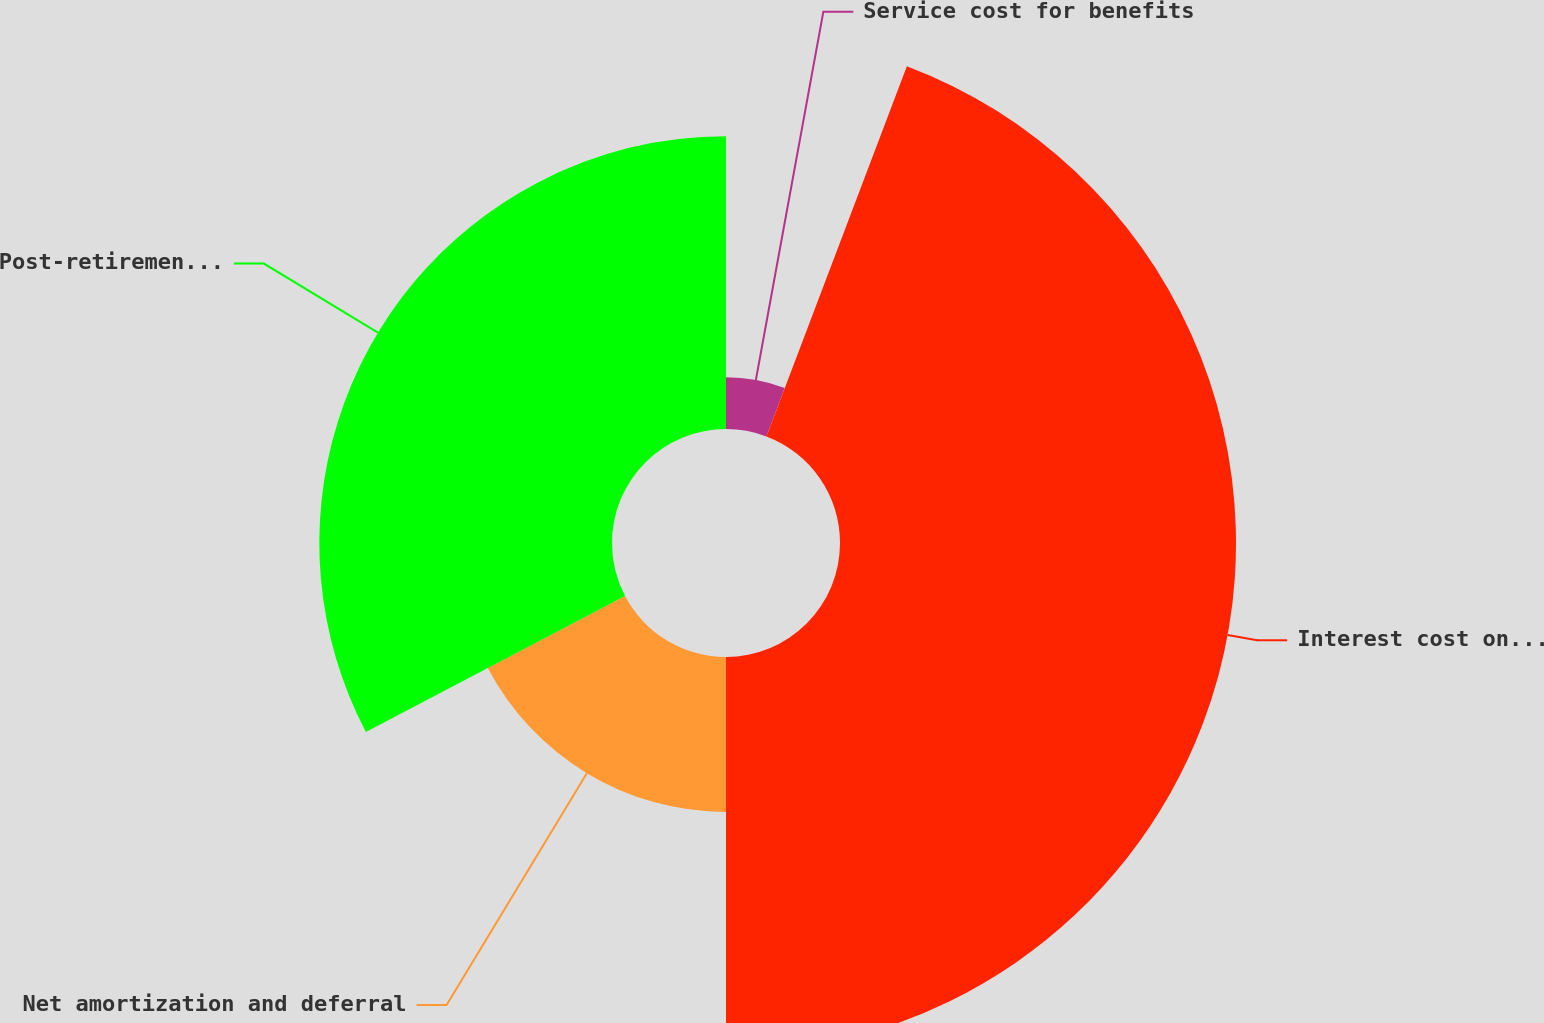Convert chart to OTSL. <chart><loc_0><loc_0><loc_500><loc_500><pie_chart><fcel>Service cost for benefits<fcel>Interest cost on benefit<fcel>Net amortization and deferral<fcel>Post-retirement medical plan<nl><fcel>5.77%<fcel>44.23%<fcel>17.31%<fcel>32.69%<nl></chart> 